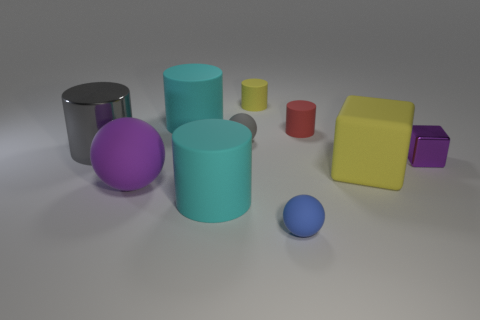There is a object that is left of the big ball; what is its material?
Offer a terse response. Metal. How many blue objects have the same shape as the purple shiny thing?
Provide a short and direct response. 0. What shape is the large yellow thing that is the same material as the tiny blue thing?
Offer a very short reply. Cube. What shape is the large cyan object that is to the left of the big cyan matte cylinder in front of the big thing on the right side of the tiny blue matte sphere?
Offer a very short reply. Cylinder. Are there more big purple spheres than small blue cylinders?
Keep it short and to the point. Yes. There is another tiny thing that is the same shape as the small gray object; what is it made of?
Make the answer very short. Rubber. Is the material of the tiny blue ball the same as the tiny red object?
Give a very brief answer. Yes. Is the number of large cylinders that are to the right of the large metal cylinder greater than the number of large matte spheres?
Keep it short and to the point. Yes. What is the material of the cyan thing that is behind the metal object that is left of the yellow cube that is right of the purple rubber thing?
Offer a terse response. Rubber. How many objects are either big yellow matte things or things that are in front of the yellow cylinder?
Provide a succinct answer. 9. 